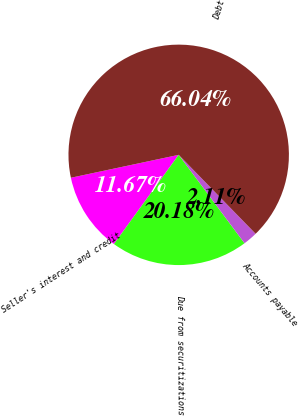Convert chart to OTSL. <chart><loc_0><loc_0><loc_500><loc_500><pie_chart><fcel>Seller's interest and credit<fcel>Due from securitizations<fcel>Accounts payable<fcel>Debt<nl><fcel>11.67%<fcel>20.18%<fcel>2.11%<fcel>66.03%<nl></chart> 